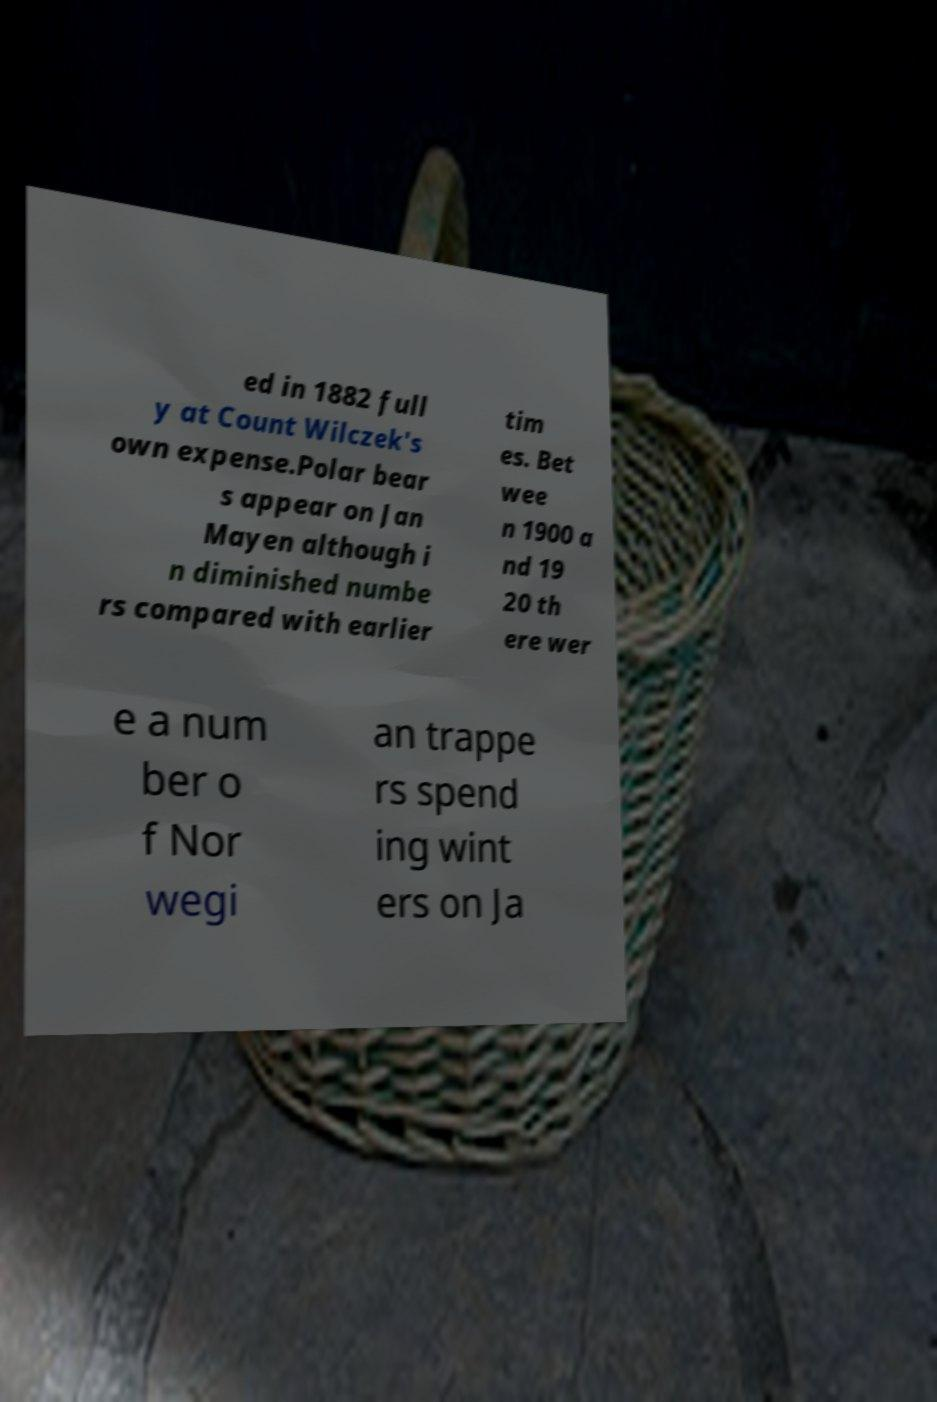Could you assist in decoding the text presented in this image and type it out clearly? ed in 1882 full y at Count Wilczek's own expense.Polar bear s appear on Jan Mayen although i n diminished numbe rs compared with earlier tim es. Bet wee n 1900 a nd 19 20 th ere wer e a num ber o f Nor wegi an trappe rs spend ing wint ers on Ja 